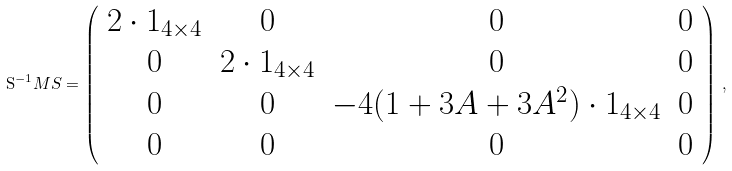Convert formula to latex. <formula><loc_0><loc_0><loc_500><loc_500>\mathrm S ^ { - 1 } M S = \left ( \begin{array} { c c c c } 2 \cdot 1 _ { 4 \times 4 } & 0 & 0 & 0 \\ 0 & 2 \cdot 1 _ { 4 \times 4 } & 0 & 0 \\ 0 & 0 & - 4 ( 1 + 3 A + 3 A ^ { 2 } ) \cdot 1 _ { 4 \times 4 } & 0 \\ 0 & 0 & 0 & 0 \end{array} \right ) \, ,</formula> 